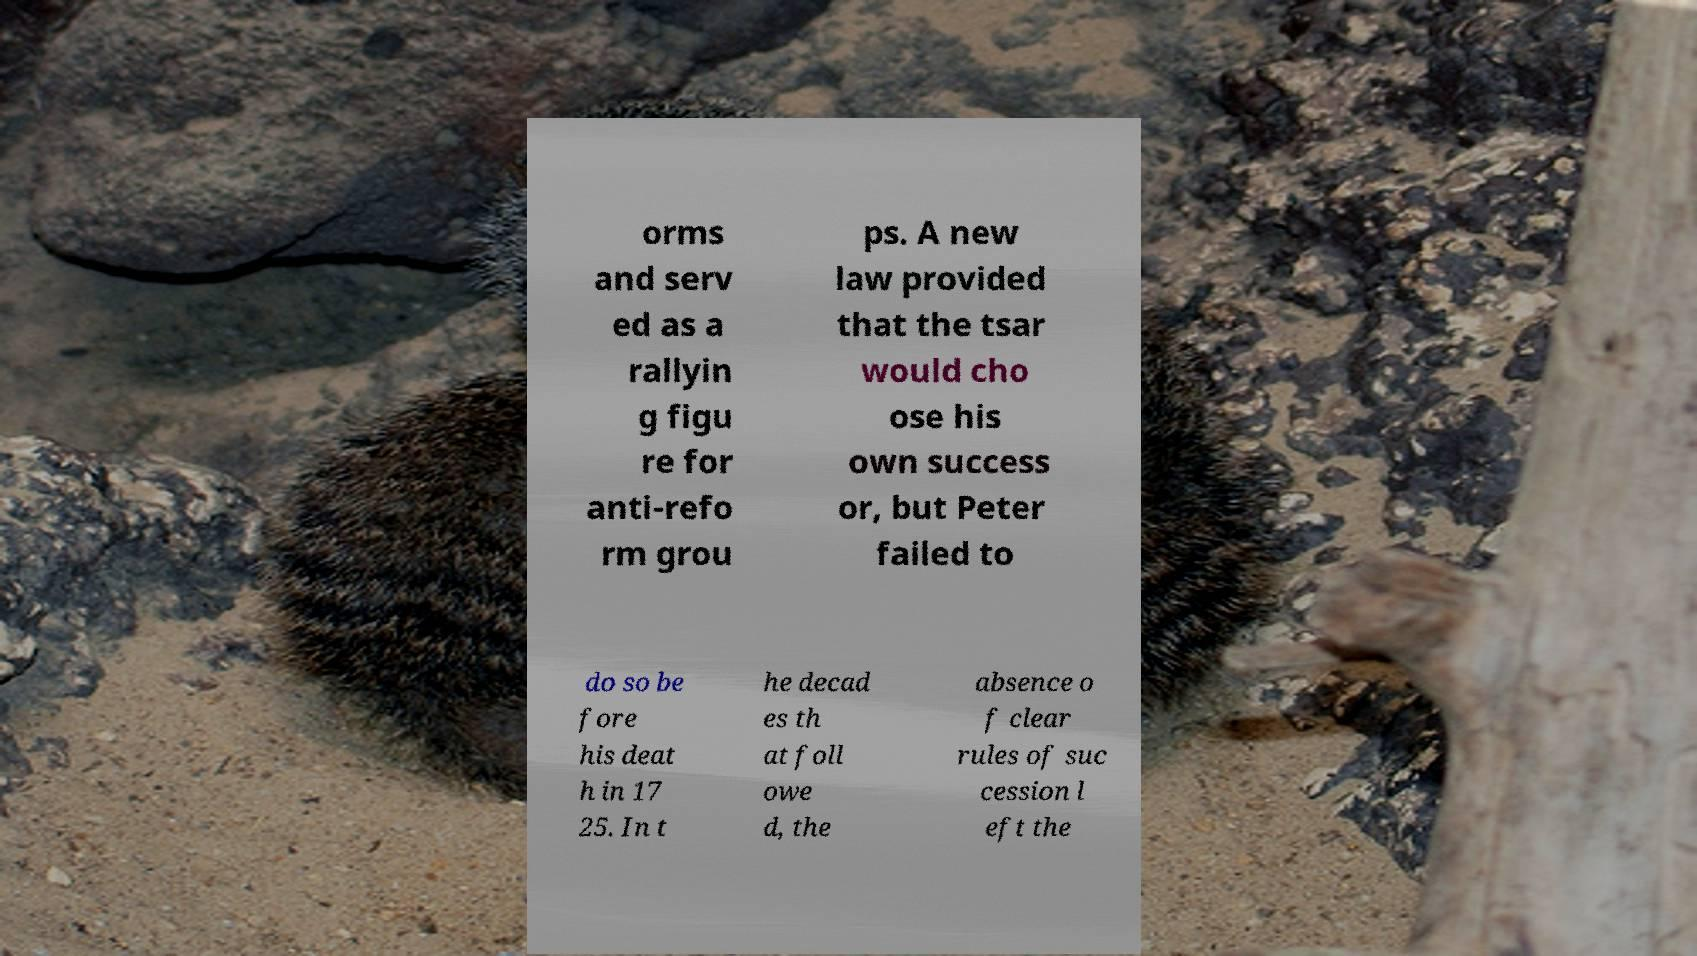Could you extract and type out the text from this image? orms and serv ed as a rallyin g figu re for anti-refo rm grou ps. A new law provided that the tsar would cho ose his own success or, but Peter failed to do so be fore his deat h in 17 25. In t he decad es th at foll owe d, the absence o f clear rules of suc cession l eft the 